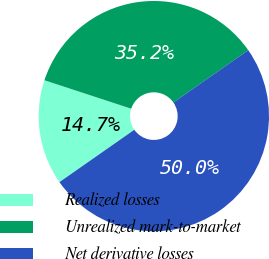<chart> <loc_0><loc_0><loc_500><loc_500><pie_chart><fcel>Realized losses<fcel>Unrealized mark-to-market<fcel>Net derivative losses<nl><fcel>14.75%<fcel>35.25%<fcel>50.0%<nl></chart> 